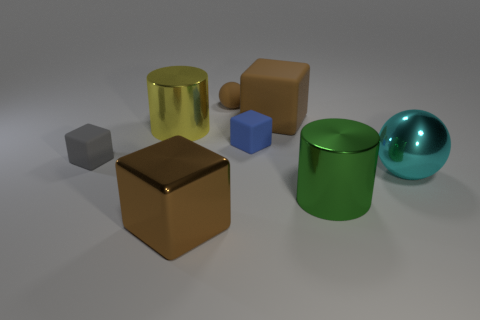How many tiny things are the same material as the small brown ball?
Give a very brief answer. 2. What number of matte objects are big purple things or big green things?
Provide a succinct answer. 0. Do the brown object left of the tiny brown thing and the large cyan metallic thing in front of the large yellow thing have the same shape?
Offer a very short reply. No. What is the color of the object that is both in front of the yellow cylinder and left of the big brown metallic cube?
Ensure brevity in your answer.  Gray. There is a brown cube behind the big cyan sphere; is it the same size as the shiny thing in front of the green shiny thing?
Give a very brief answer. Yes. How many metal cylinders are the same color as the large ball?
Keep it short and to the point. 0. What number of small things are red metal things or yellow shiny objects?
Give a very brief answer. 0. Does the sphere to the right of the big matte thing have the same material as the green cylinder?
Ensure brevity in your answer.  Yes. There is a big cube right of the small brown matte object; what color is it?
Your answer should be very brief. Brown. Is there a brown rubber block of the same size as the yellow shiny thing?
Make the answer very short. Yes. 